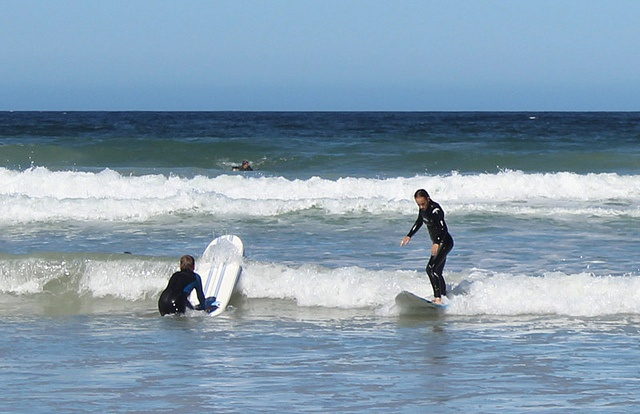Describe the objects in this image and their specific colors. I can see surfboard in lightblue, lightgray, darkgray, and gray tones, people in lightblue, black, gray, darkgray, and lightgray tones, people in lightblue, black, navy, gray, and darkblue tones, surfboard in lightblue, gray, darkgray, and lightgray tones, and people in lightblue, black, gray, and purple tones in this image. 